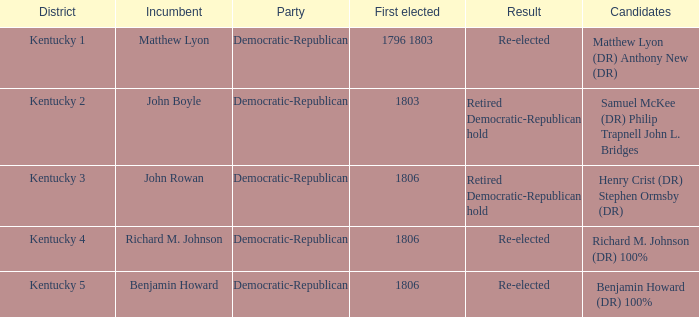Name the first elected for kentucky 3 1806.0. 